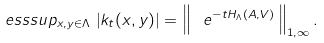Convert formula to latex. <formula><loc_0><loc_0><loc_500><loc_500>\ e s s s u p _ { x , y \in \Lambda } \, \left | k _ { t } ( x , y ) \right | = \left \| \, \ e ^ { - t H _ { \Lambda } ( A , V ) } \, \right \| _ { 1 , \infty } .</formula> 